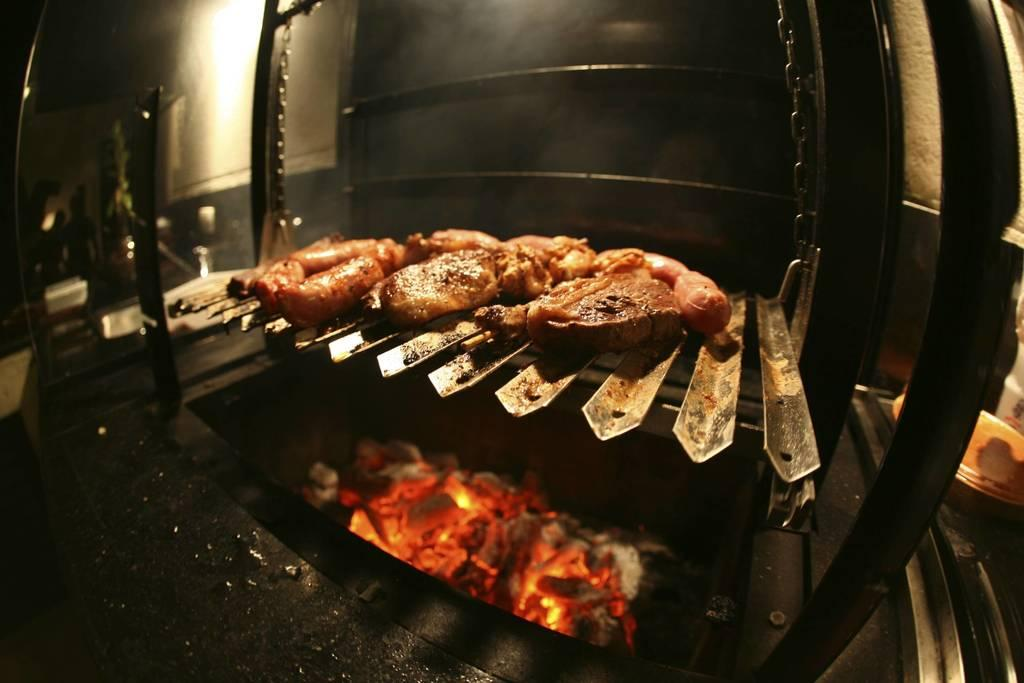What is the main subject of the image? The main subject of the image is food. Where is the food located in the image? The food is on a grill stove. What is used to cook the food on the grill stove? There is fire under the grills. What is the color scheme of the background wall in the image? The background wall has a white and black color scheme. What is the weather like during the week in the image? The image does not provide information about the weather or the week, as it focuses on the food and grill stove. 